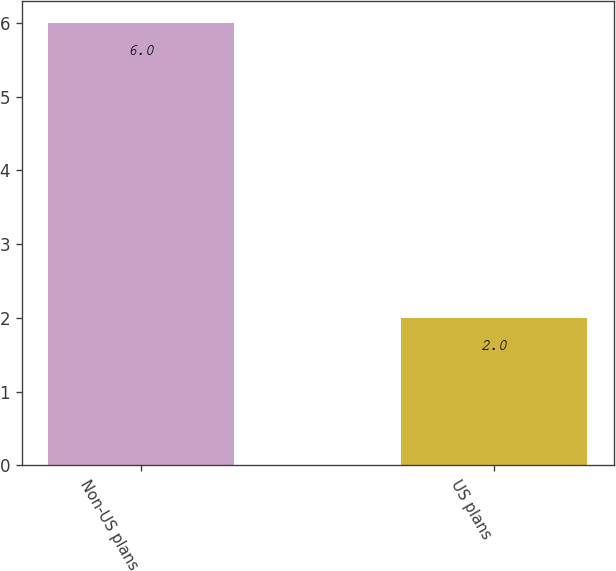Convert chart. <chart><loc_0><loc_0><loc_500><loc_500><bar_chart><fcel>Non-US plans<fcel>US plans<nl><fcel>6<fcel>2<nl></chart> 